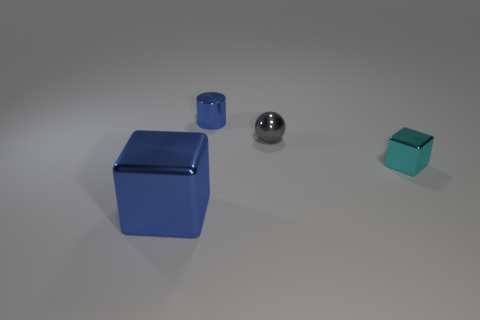Which object in the image reflects the most light? The sphere in the image reflects the most light, showing a clear highlight and several reflections due to its highly reflective, smooth metallic surface. 